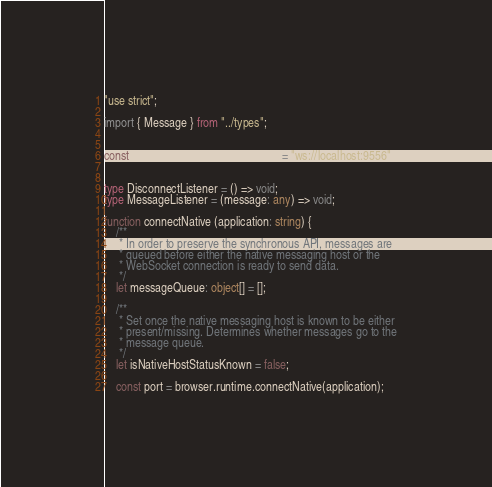Convert code to text. <code><loc_0><loc_0><loc_500><loc_500><_TypeScript_>"use strict";

import { Message } from "../types";


const WEBSOCKET_DAEMON_URL = "ws://localhost:9556";


type DisconnectListener = () => void;
type MessageListener = (message: any) => void;

function connectNative (application: string) {
    /**
     * In order to preserve the synchronous API, messages are
     * queued before either the native messaging host or the
     * WebSocket connection is ready to send data.
     */
    let messageQueue: object[] = [];

    /**
     * Set once the native messaging host is known to be either
     * present/missing. Determines whether messages go to the
     * message queue.
     */
    let isNativeHostStatusKnown = false;

    const port = browser.runtime.connectNative(application);

</code> 